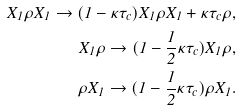<formula> <loc_0><loc_0><loc_500><loc_500>X _ { 1 } \rho X _ { 1 } \rightarrow ( 1 - \kappa \tau _ { c } ) X _ { 1 } \rho X _ { 1 } + \kappa \tau _ { c } \rho , \\ X _ { 1 } \rho \rightarrow ( 1 - \frac { 1 } { 2 } \kappa \tau _ { c } ) X _ { 1 } \rho , \\ \rho X _ { 1 } \rightarrow ( 1 - \frac { 1 } { 2 } \kappa \tau _ { c } ) \rho X _ { 1 } .</formula> 